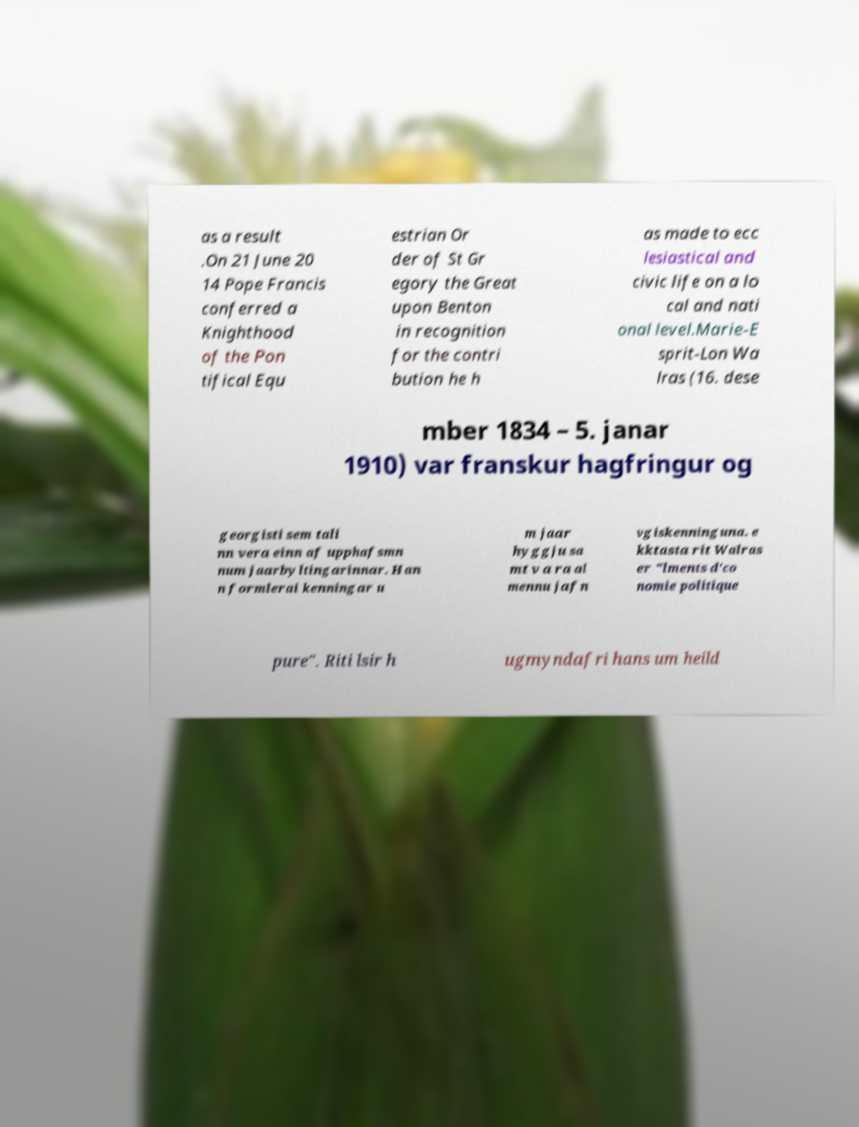What messages or text are displayed in this image? I need them in a readable, typed format. as a result .On 21 June 20 14 Pope Francis conferred a Knighthood of the Pon tifical Equ estrian Or der of St Gr egory the Great upon Benton in recognition for the contri bution he h as made to ecc lesiastical and civic life on a lo cal and nati onal level.Marie-E sprit-Lon Wa lras (16. dese mber 1834 – 5. janar 1910) var franskur hagfringur og georgisti sem tali nn vera einn af upphafsmn num jaarbyltingarinnar. Han n formlerai kenningar u m jaar hyggju sa mt v a ra al mennu jafn vgiskenninguna. e kktasta rit Walras er "lments d'co nomie politique pure". Riti lsir h ugmyndafri hans um heild 